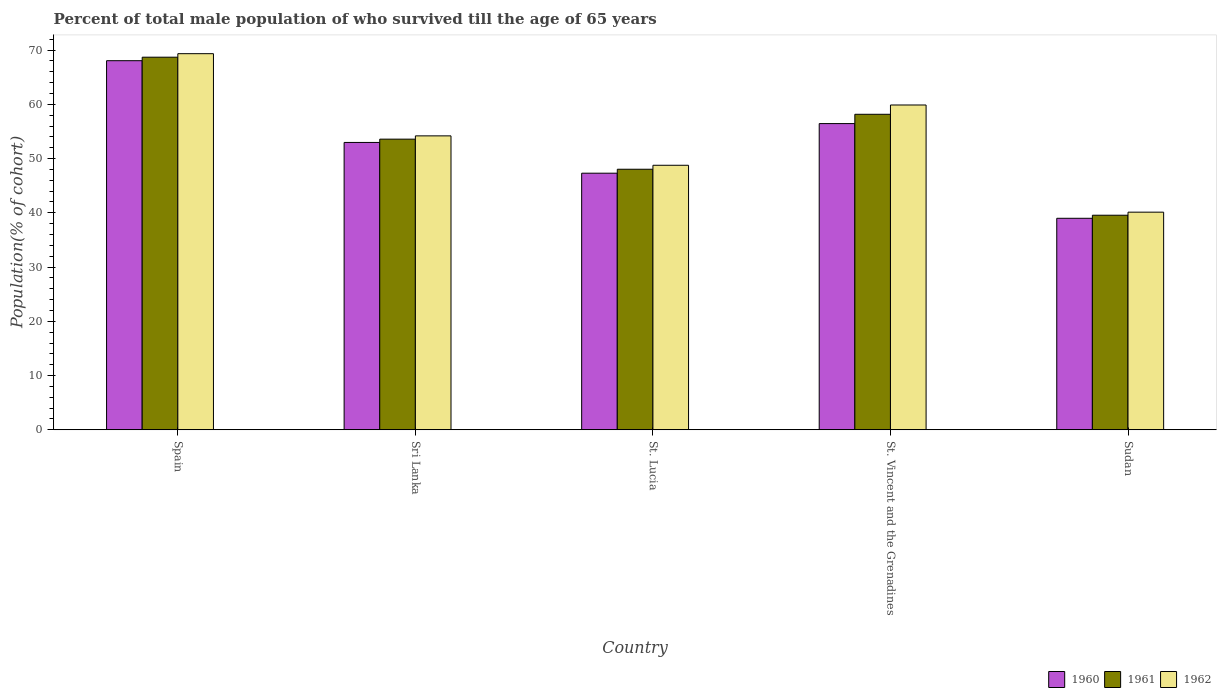How many different coloured bars are there?
Ensure brevity in your answer.  3. Are the number of bars on each tick of the X-axis equal?
Provide a succinct answer. Yes. What is the label of the 2nd group of bars from the left?
Provide a succinct answer. Sri Lanka. What is the percentage of total male population who survived till the age of 65 years in 1961 in St. Vincent and the Grenadines?
Your answer should be compact. 58.16. Across all countries, what is the maximum percentage of total male population who survived till the age of 65 years in 1961?
Offer a very short reply. 68.69. Across all countries, what is the minimum percentage of total male population who survived till the age of 65 years in 1962?
Offer a terse response. 40.12. In which country was the percentage of total male population who survived till the age of 65 years in 1960 maximum?
Provide a succinct answer. Spain. In which country was the percentage of total male population who survived till the age of 65 years in 1962 minimum?
Offer a very short reply. Sudan. What is the total percentage of total male population who survived till the age of 65 years in 1961 in the graph?
Keep it short and to the point. 268.03. What is the difference between the percentage of total male population who survived till the age of 65 years in 1960 in St. Vincent and the Grenadines and that in Sudan?
Your answer should be compact. 17.46. What is the difference between the percentage of total male population who survived till the age of 65 years in 1962 in Sri Lanka and the percentage of total male population who survived till the age of 65 years in 1961 in St. Lucia?
Your answer should be very brief. 6.15. What is the average percentage of total male population who survived till the age of 65 years in 1960 per country?
Your answer should be compact. 52.75. What is the difference between the percentage of total male population who survived till the age of 65 years of/in 1960 and percentage of total male population who survived till the age of 65 years of/in 1962 in Sudan?
Make the answer very short. -1.13. In how many countries, is the percentage of total male population who survived till the age of 65 years in 1961 greater than 24 %?
Your answer should be compact. 5. What is the ratio of the percentage of total male population who survived till the age of 65 years in 1961 in St. Lucia to that in St. Vincent and the Grenadines?
Offer a terse response. 0.83. Is the percentage of total male population who survived till the age of 65 years in 1962 in Spain less than that in St. Lucia?
Ensure brevity in your answer.  No. Is the difference between the percentage of total male population who survived till the age of 65 years in 1960 in St. Lucia and St. Vincent and the Grenadines greater than the difference between the percentage of total male population who survived till the age of 65 years in 1962 in St. Lucia and St. Vincent and the Grenadines?
Your response must be concise. Yes. What is the difference between the highest and the second highest percentage of total male population who survived till the age of 65 years in 1960?
Keep it short and to the point. -11.59. What is the difference between the highest and the lowest percentage of total male population who survived till the age of 65 years in 1960?
Your answer should be compact. 29.05. In how many countries, is the percentage of total male population who survived till the age of 65 years in 1961 greater than the average percentage of total male population who survived till the age of 65 years in 1961 taken over all countries?
Your answer should be very brief. 2. What does the 3rd bar from the left in St. Vincent and the Grenadines represents?
Offer a terse response. 1962. Is it the case that in every country, the sum of the percentage of total male population who survived till the age of 65 years in 1962 and percentage of total male population who survived till the age of 65 years in 1960 is greater than the percentage of total male population who survived till the age of 65 years in 1961?
Your answer should be compact. Yes. What is the difference between two consecutive major ticks on the Y-axis?
Your answer should be very brief. 10. Are the values on the major ticks of Y-axis written in scientific E-notation?
Provide a succinct answer. No. Does the graph contain any zero values?
Give a very brief answer. No. How many legend labels are there?
Ensure brevity in your answer.  3. What is the title of the graph?
Offer a terse response. Percent of total male population of who survived till the age of 65 years. What is the label or title of the Y-axis?
Offer a terse response. Population(% of cohort). What is the Population(% of cohort) in 1960 in Spain?
Your answer should be compact. 68.04. What is the Population(% of cohort) in 1961 in Spain?
Provide a short and direct response. 68.69. What is the Population(% of cohort) of 1962 in Spain?
Provide a succinct answer. 69.34. What is the Population(% of cohort) in 1960 in Sri Lanka?
Offer a terse response. 52.97. What is the Population(% of cohort) of 1961 in Sri Lanka?
Your answer should be very brief. 53.58. What is the Population(% of cohort) of 1962 in Sri Lanka?
Provide a succinct answer. 54.19. What is the Population(% of cohort) of 1960 in St. Lucia?
Make the answer very short. 47.31. What is the Population(% of cohort) of 1961 in St. Lucia?
Your answer should be very brief. 48.04. What is the Population(% of cohort) in 1962 in St. Lucia?
Offer a very short reply. 48.77. What is the Population(% of cohort) of 1960 in St. Vincent and the Grenadines?
Keep it short and to the point. 56.45. What is the Population(% of cohort) in 1961 in St. Vincent and the Grenadines?
Your answer should be compact. 58.16. What is the Population(% of cohort) in 1962 in St. Vincent and the Grenadines?
Offer a terse response. 59.88. What is the Population(% of cohort) of 1960 in Sudan?
Give a very brief answer. 38.99. What is the Population(% of cohort) in 1961 in Sudan?
Your answer should be compact. 39.56. What is the Population(% of cohort) in 1962 in Sudan?
Offer a terse response. 40.12. Across all countries, what is the maximum Population(% of cohort) of 1960?
Offer a terse response. 68.04. Across all countries, what is the maximum Population(% of cohort) of 1961?
Your answer should be compact. 68.69. Across all countries, what is the maximum Population(% of cohort) in 1962?
Make the answer very short. 69.34. Across all countries, what is the minimum Population(% of cohort) in 1960?
Make the answer very short. 38.99. Across all countries, what is the minimum Population(% of cohort) in 1961?
Keep it short and to the point. 39.56. Across all countries, what is the minimum Population(% of cohort) in 1962?
Your answer should be very brief. 40.12. What is the total Population(% of cohort) of 1960 in the graph?
Your answer should be very brief. 263.77. What is the total Population(% of cohort) of 1961 in the graph?
Your response must be concise. 268.03. What is the total Population(% of cohort) of 1962 in the graph?
Your response must be concise. 272.29. What is the difference between the Population(% of cohort) in 1960 in Spain and that in Sri Lanka?
Provide a succinct answer. 15.07. What is the difference between the Population(% of cohort) of 1961 in Spain and that in Sri Lanka?
Your response must be concise. 15.11. What is the difference between the Population(% of cohort) in 1962 in Spain and that in Sri Lanka?
Provide a succinct answer. 15.15. What is the difference between the Population(% of cohort) in 1960 in Spain and that in St. Lucia?
Your answer should be very brief. 20.74. What is the difference between the Population(% of cohort) in 1961 in Spain and that in St. Lucia?
Keep it short and to the point. 20.66. What is the difference between the Population(% of cohort) in 1962 in Spain and that in St. Lucia?
Give a very brief answer. 20.57. What is the difference between the Population(% of cohort) of 1960 in Spain and that in St. Vincent and the Grenadines?
Provide a short and direct response. 11.59. What is the difference between the Population(% of cohort) in 1961 in Spain and that in St. Vincent and the Grenadines?
Make the answer very short. 10.53. What is the difference between the Population(% of cohort) in 1962 in Spain and that in St. Vincent and the Grenadines?
Offer a very short reply. 9.46. What is the difference between the Population(% of cohort) in 1960 in Spain and that in Sudan?
Keep it short and to the point. 29.05. What is the difference between the Population(% of cohort) of 1961 in Spain and that in Sudan?
Your answer should be compact. 29.13. What is the difference between the Population(% of cohort) of 1962 in Spain and that in Sudan?
Your answer should be compact. 29.21. What is the difference between the Population(% of cohort) of 1960 in Sri Lanka and that in St. Lucia?
Ensure brevity in your answer.  5.67. What is the difference between the Population(% of cohort) in 1961 in Sri Lanka and that in St. Lucia?
Your response must be concise. 5.54. What is the difference between the Population(% of cohort) of 1962 in Sri Lanka and that in St. Lucia?
Provide a succinct answer. 5.42. What is the difference between the Population(% of cohort) in 1960 in Sri Lanka and that in St. Vincent and the Grenadines?
Give a very brief answer. -3.48. What is the difference between the Population(% of cohort) of 1961 in Sri Lanka and that in St. Vincent and the Grenadines?
Your answer should be compact. -4.58. What is the difference between the Population(% of cohort) in 1962 in Sri Lanka and that in St. Vincent and the Grenadines?
Give a very brief answer. -5.69. What is the difference between the Population(% of cohort) of 1960 in Sri Lanka and that in Sudan?
Offer a terse response. 13.98. What is the difference between the Population(% of cohort) in 1961 in Sri Lanka and that in Sudan?
Make the answer very short. 14.02. What is the difference between the Population(% of cohort) in 1962 in Sri Lanka and that in Sudan?
Give a very brief answer. 14.06. What is the difference between the Population(% of cohort) of 1960 in St. Lucia and that in St. Vincent and the Grenadines?
Provide a succinct answer. -9.15. What is the difference between the Population(% of cohort) in 1961 in St. Lucia and that in St. Vincent and the Grenadines?
Provide a short and direct response. -10.13. What is the difference between the Population(% of cohort) in 1962 in St. Lucia and that in St. Vincent and the Grenadines?
Ensure brevity in your answer.  -11.11. What is the difference between the Population(% of cohort) in 1960 in St. Lucia and that in Sudan?
Offer a very short reply. 8.31. What is the difference between the Population(% of cohort) in 1961 in St. Lucia and that in Sudan?
Your answer should be compact. 8.48. What is the difference between the Population(% of cohort) of 1962 in St. Lucia and that in Sudan?
Give a very brief answer. 8.64. What is the difference between the Population(% of cohort) in 1960 in St. Vincent and the Grenadines and that in Sudan?
Your answer should be very brief. 17.46. What is the difference between the Population(% of cohort) in 1961 in St. Vincent and the Grenadines and that in Sudan?
Your answer should be compact. 18.61. What is the difference between the Population(% of cohort) in 1962 in St. Vincent and the Grenadines and that in Sudan?
Your answer should be compact. 19.75. What is the difference between the Population(% of cohort) in 1960 in Spain and the Population(% of cohort) in 1961 in Sri Lanka?
Offer a terse response. 14.46. What is the difference between the Population(% of cohort) in 1960 in Spain and the Population(% of cohort) in 1962 in Sri Lanka?
Your answer should be compact. 13.86. What is the difference between the Population(% of cohort) of 1961 in Spain and the Population(% of cohort) of 1962 in Sri Lanka?
Your response must be concise. 14.5. What is the difference between the Population(% of cohort) of 1960 in Spain and the Population(% of cohort) of 1961 in St. Lucia?
Give a very brief answer. 20.01. What is the difference between the Population(% of cohort) in 1960 in Spain and the Population(% of cohort) in 1962 in St. Lucia?
Offer a very short reply. 19.28. What is the difference between the Population(% of cohort) of 1961 in Spain and the Population(% of cohort) of 1962 in St. Lucia?
Offer a very short reply. 19.93. What is the difference between the Population(% of cohort) in 1960 in Spain and the Population(% of cohort) in 1961 in St. Vincent and the Grenadines?
Provide a short and direct response. 9.88. What is the difference between the Population(% of cohort) in 1960 in Spain and the Population(% of cohort) in 1962 in St. Vincent and the Grenadines?
Offer a very short reply. 8.17. What is the difference between the Population(% of cohort) of 1961 in Spain and the Population(% of cohort) of 1962 in St. Vincent and the Grenadines?
Keep it short and to the point. 8.81. What is the difference between the Population(% of cohort) of 1960 in Spain and the Population(% of cohort) of 1961 in Sudan?
Provide a short and direct response. 28.49. What is the difference between the Population(% of cohort) in 1960 in Spain and the Population(% of cohort) in 1962 in Sudan?
Give a very brief answer. 27.92. What is the difference between the Population(% of cohort) of 1961 in Spain and the Population(% of cohort) of 1962 in Sudan?
Your answer should be compact. 28.57. What is the difference between the Population(% of cohort) in 1960 in Sri Lanka and the Population(% of cohort) in 1961 in St. Lucia?
Provide a short and direct response. 4.94. What is the difference between the Population(% of cohort) of 1960 in Sri Lanka and the Population(% of cohort) of 1962 in St. Lucia?
Your answer should be very brief. 4.21. What is the difference between the Population(% of cohort) of 1961 in Sri Lanka and the Population(% of cohort) of 1962 in St. Lucia?
Your answer should be very brief. 4.81. What is the difference between the Population(% of cohort) of 1960 in Sri Lanka and the Population(% of cohort) of 1961 in St. Vincent and the Grenadines?
Give a very brief answer. -5.19. What is the difference between the Population(% of cohort) in 1960 in Sri Lanka and the Population(% of cohort) in 1962 in St. Vincent and the Grenadines?
Provide a short and direct response. -6.9. What is the difference between the Population(% of cohort) of 1961 in Sri Lanka and the Population(% of cohort) of 1962 in St. Vincent and the Grenadines?
Offer a terse response. -6.3. What is the difference between the Population(% of cohort) of 1960 in Sri Lanka and the Population(% of cohort) of 1961 in Sudan?
Ensure brevity in your answer.  13.42. What is the difference between the Population(% of cohort) of 1960 in Sri Lanka and the Population(% of cohort) of 1962 in Sudan?
Offer a very short reply. 12.85. What is the difference between the Population(% of cohort) of 1961 in Sri Lanka and the Population(% of cohort) of 1962 in Sudan?
Keep it short and to the point. 13.46. What is the difference between the Population(% of cohort) in 1960 in St. Lucia and the Population(% of cohort) in 1961 in St. Vincent and the Grenadines?
Offer a very short reply. -10.86. What is the difference between the Population(% of cohort) in 1960 in St. Lucia and the Population(% of cohort) in 1962 in St. Vincent and the Grenadines?
Provide a short and direct response. -12.57. What is the difference between the Population(% of cohort) of 1961 in St. Lucia and the Population(% of cohort) of 1962 in St. Vincent and the Grenadines?
Offer a terse response. -11.84. What is the difference between the Population(% of cohort) in 1960 in St. Lucia and the Population(% of cohort) in 1961 in Sudan?
Your response must be concise. 7.75. What is the difference between the Population(% of cohort) in 1960 in St. Lucia and the Population(% of cohort) in 1962 in Sudan?
Provide a succinct answer. 7.18. What is the difference between the Population(% of cohort) in 1961 in St. Lucia and the Population(% of cohort) in 1962 in Sudan?
Keep it short and to the point. 7.91. What is the difference between the Population(% of cohort) in 1960 in St. Vincent and the Grenadines and the Population(% of cohort) in 1961 in Sudan?
Provide a succinct answer. 16.89. What is the difference between the Population(% of cohort) in 1960 in St. Vincent and the Grenadines and the Population(% of cohort) in 1962 in Sudan?
Provide a short and direct response. 16.33. What is the difference between the Population(% of cohort) of 1961 in St. Vincent and the Grenadines and the Population(% of cohort) of 1962 in Sudan?
Your response must be concise. 18.04. What is the average Population(% of cohort) in 1960 per country?
Give a very brief answer. 52.75. What is the average Population(% of cohort) of 1961 per country?
Ensure brevity in your answer.  53.61. What is the average Population(% of cohort) of 1962 per country?
Ensure brevity in your answer.  54.46. What is the difference between the Population(% of cohort) of 1960 and Population(% of cohort) of 1961 in Spain?
Provide a succinct answer. -0.65. What is the difference between the Population(% of cohort) in 1960 and Population(% of cohort) in 1962 in Spain?
Ensure brevity in your answer.  -1.29. What is the difference between the Population(% of cohort) in 1961 and Population(% of cohort) in 1962 in Spain?
Make the answer very short. -0.65. What is the difference between the Population(% of cohort) of 1960 and Population(% of cohort) of 1961 in Sri Lanka?
Keep it short and to the point. -0.61. What is the difference between the Population(% of cohort) in 1960 and Population(% of cohort) in 1962 in Sri Lanka?
Provide a short and direct response. -1.21. What is the difference between the Population(% of cohort) in 1961 and Population(% of cohort) in 1962 in Sri Lanka?
Give a very brief answer. -0.61. What is the difference between the Population(% of cohort) of 1960 and Population(% of cohort) of 1961 in St. Lucia?
Make the answer very short. -0.73. What is the difference between the Population(% of cohort) of 1960 and Population(% of cohort) of 1962 in St. Lucia?
Offer a very short reply. -1.46. What is the difference between the Population(% of cohort) in 1961 and Population(% of cohort) in 1962 in St. Lucia?
Provide a short and direct response. -0.73. What is the difference between the Population(% of cohort) in 1960 and Population(% of cohort) in 1961 in St. Vincent and the Grenadines?
Offer a terse response. -1.71. What is the difference between the Population(% of cohort) in 1960 and Population(% of cohort) in 1962 in St. Vincent and the Grenadines?
Give a very brief answer. -3.43. What is the difference between the Population(% of cohort) of 1961 and Population(% of cohort) of 1962 in St. Vincent and the Grenadines?
Your answer should be very brief. -1.71. What is the difference between the Population(% of cohort) in 1960 and Population(% of cohort) in 1961 in Sudan?
Give a very brief answer. -0.57. What is the difference between the Population(% of cohort) of 1960 and Population(% of cohort) of 1962 in Sudan?
Your response must be concise. -1.13. What is the difference between the Population(% of cohort) of 1961 and Population(% of cohort) of 1962 in Sudan?
Your answer should be very brief. -0.57. What is the ratio of the Population(% of cohort) of 1960 in Spain to that in Sri Lanka?
Give a very brief answer. 1.28. What is the ratio of the Population(% of cohort) in 1961 in Spain to that in Sri Lanka?
Provide a succinct answer. 1.28. What is the ratio of the Population(% of cohort) in 1962 in Spain to that in Sri Lanka?
Your answer should be compact. 1.28. What is the ratio of the Population(% of cohort) of 1960 in Spain to that in St. Lucia?
Provide a succinct answer. 1.44. What is the ratio of the Population(% of cohort) of 1961 in Spain to that in St. Lucia?
Your response must be concise. 1.43. What is the ratio of the Population(% of cohort) in 1962 in Spain to that in St. Lucia?
Your response must be concise. 1.42. What is the ratio of the Population(% of cohort) of 1960 in Spain to that in St. Vincent and the Grenadines?
Ensure brevity in your answer.  1.21. What is the ratio of the Population(% of cohort) of 1961 in Spain to that in St. Vincent and the Grenadines?
Offer a terse response. 1.18. What is the ratio of the Population(% of cohort) of 1962 in Spain to that in St. Vincent and the Grenadines?
Your answer should be very brief. 1.16. What is the ratio of the Population(% of cohort) of 1960 in Spain to that in Sudan?
Make the answer very short. 1.75. What is the ratio of the Population(% of cohort) in 1961 in Spain to that in Sudan?
Your answer should be very brief. 1.74. What is the ratio of the Population(% of cohort) in 1962 in Spain to that in Sudan?
Give a very brief answer. 1.73. What is the ratio of the Population(% of cohort) of 1960 in Sri Lanka to that in St. Lucia?
Keep it short and to the point. 1.12. What is the ratio of the Population(% of cohort) in 1961 in Sri Lanka to that in St. Lucia?
Provide a short and direct response. 1.12. What is the ratio of the Population(% of cohort) in 1962 in Sri Lanka to that in St. Lucia?
Your response must be concise. 1.11. What is the ratio of the Population(% of cohort) in 1960 in Sri Lanka to that in St. Vincent and the Grenadines?
Make the answer very short. 0.94. What is the ratio of the Population(% of cohort) in 1961 in Sri Lanka to that in St. Vincent and the Grenadines?
Give a very brief answer. 0.92. What is the ratio of the Population(% of cohort) in 1962 in Sri Lanka to that in St. Vincent and the Grenadines?
Your response must be concise. 0.91. What is the ratio of the Population(% of cohort) in 1960 in Sri Lanka to that in Sudan?
Your response must be concise. 1.36. What is the ratio of the Population(% of cohort) in 1961 in Sri Lanka to that in Sudan?
Ensure brevity in your answer.  1.35. What is the ratio of the Population(% of cohort) of 1962 in Sri Lanka to that in Sudan?
Offer a terse response. 1.35. What is the ratio of the Population(% of cohort) in 1960 in St. Lucia to that in St. Vincent and the Grenadines?
Offer a terse response. 0.84. What is the ratio of the Population(% of cohort) of 1961 in St. Lucia to that in St. Vincent and the Grenadines?
Offer a very short reply. 0.83. What is the ratio of the Population(% of cohort) in 1962 in St. Lucia to that in St. Vincent and the Grenadines?
Make the answer very short. 0.81. What is the ratio of the Population(% of cohort) in 1960 in St. Lucia to that in Sudan?
Keep it short and to the point. 1.21. What is the ratio of the Population(% of cohort) of 1961 in St. Lucia to that in Sudan?
Your answer should be compact. 1.21. What is the ratio of the Population(% of cohort) in 1962 in St. Lucia to that in Sudan?
Give a very brief answer. 1.22. What is the ratio of the Population(% of cohort) in 1960 in St. Vincent and the Grenadines to that in Sudan?
Provide a short and direct response. 1.45. What is the ratio of the Population(% of cohort) of 1961 in St. Vincent and the Grenadines to that in Sudan?
Provide a succinct answer. 1.47. What is the ratio of the Population(% of cohort) in 1962 in St. Vincent and the Grenadines to that in Sudan?
Your answer should be compact. 1.49. What is the difference between the highest and the second highest Population(% of cohort) of 1960?
Keep it short and to the point. 11.59. What is the difference between the highest and the second highest Population(% of cohort) of 1961?
Keep it short and to the point. 10.53. What is the difference between the highest and the second highest Population(% of cohort) in 1962?
Ensure brevity in your answer.  9.46. What is the difference between the highest and the lowest Population(% of cohort) of 1960?
Your answer should be compact. 29.05. What is the difference between the highest and the lowest Population(% of cohort) in 1961?
Make the answer very short. 29.13. What is the difference between the highest and the lowest Population(% of cohort) in 1962?
Your answer should be compact. 29.21. 